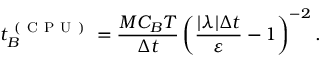<formula> <loc_0><loc_0><loc_500><loc_500>t _ { B } ^ { ( C P U ) } = \frac { M C _ { B } T } { \Delta t } \left ( \frac { | \lambda | \Delta t } { \varepsilon } - 1 \right ) ^ { - 2 } .</formula> 